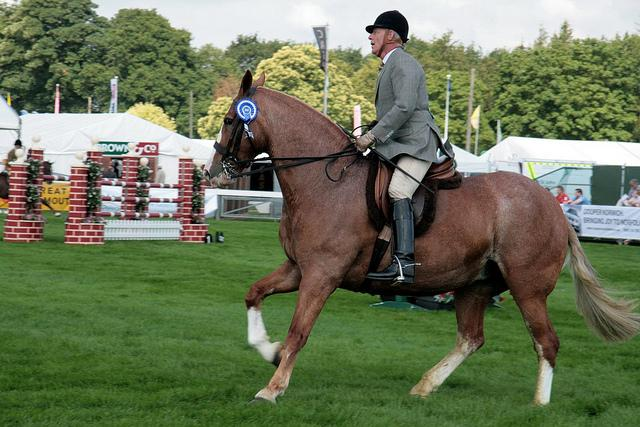What does the man have on?

Choices:
A) bow tie
B) hat
C) scarf
D) suspenders hat 